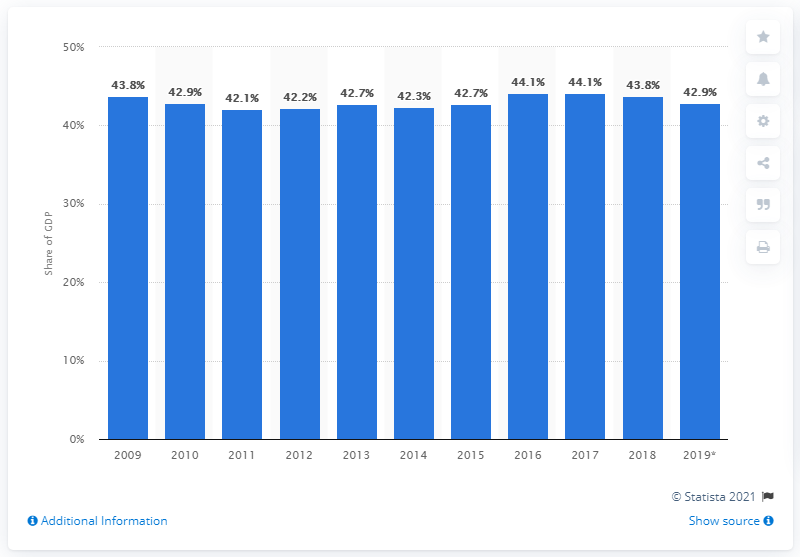Identify some key points in this picture. The tax ratio in Sweden in 2019 was 42.9%. 